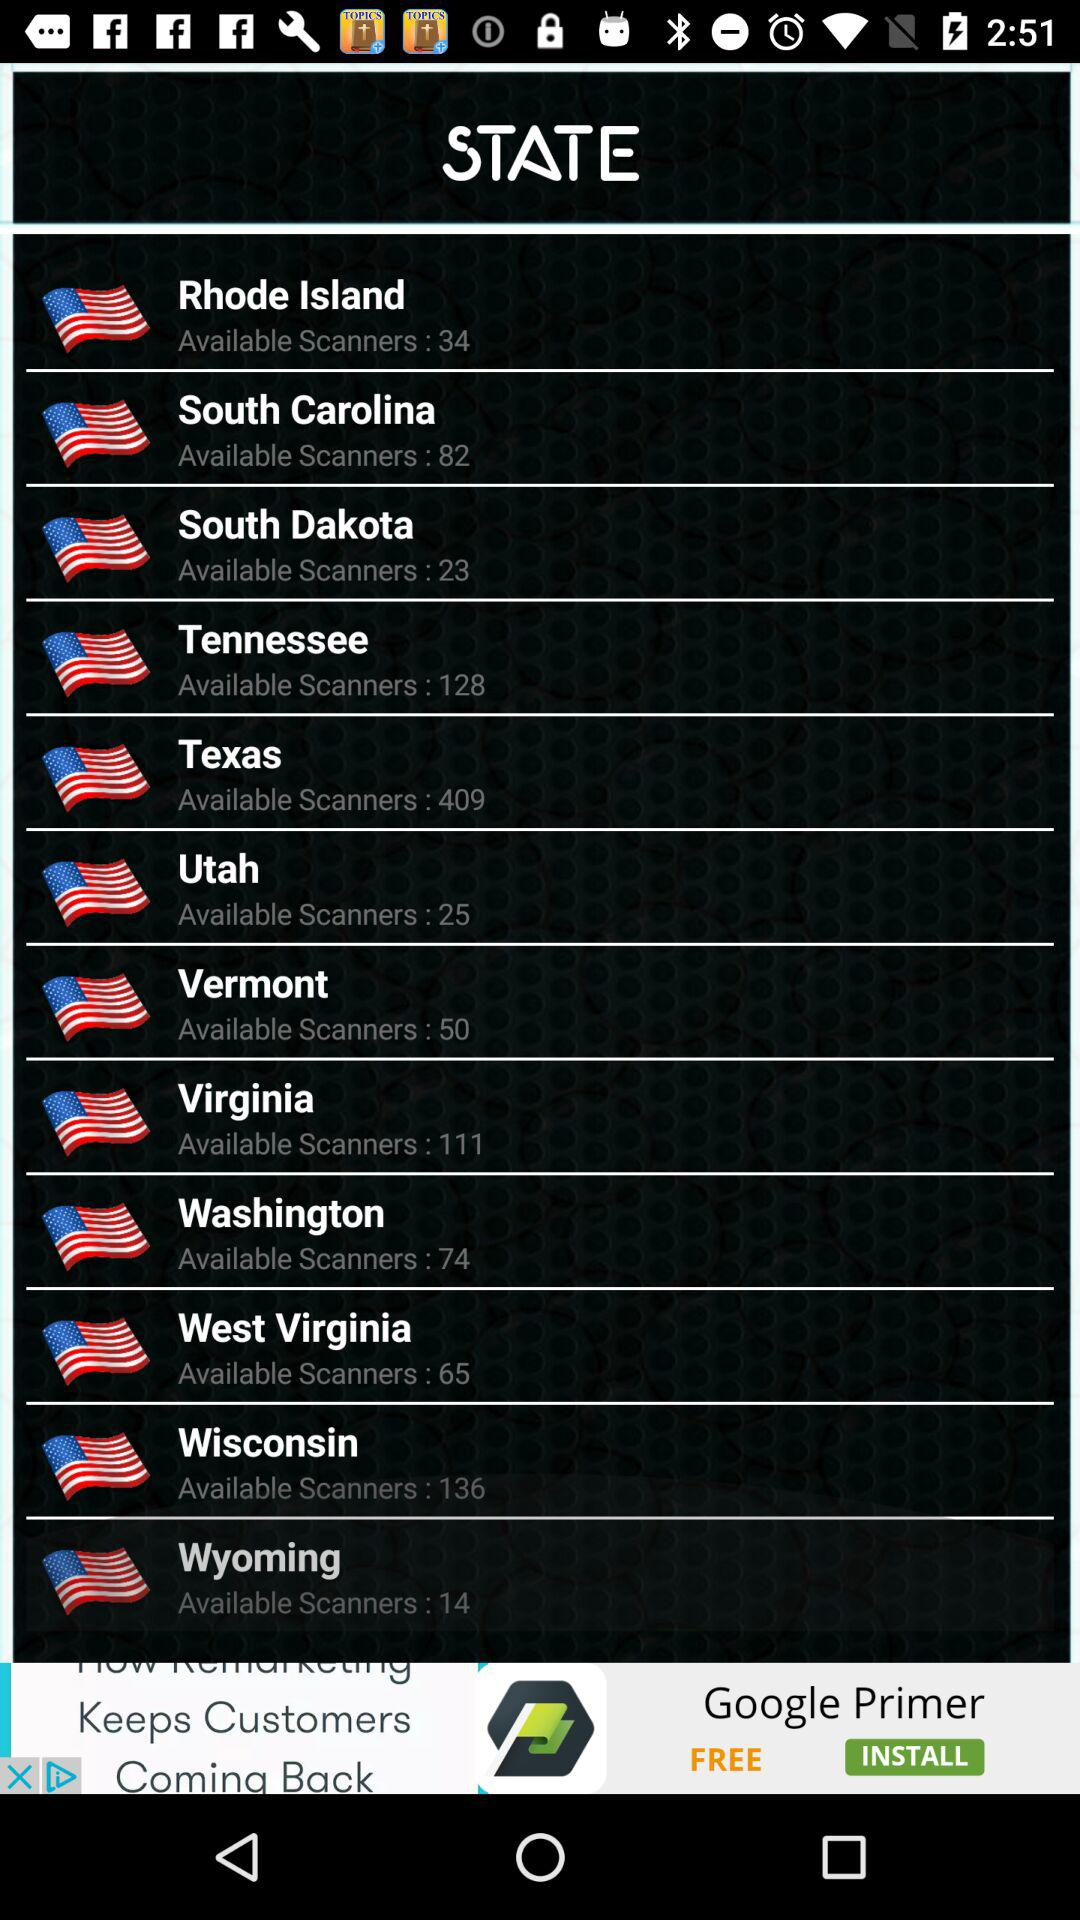Which state has the most available scanners?
Answer the question using a single word or phrase. Texas 